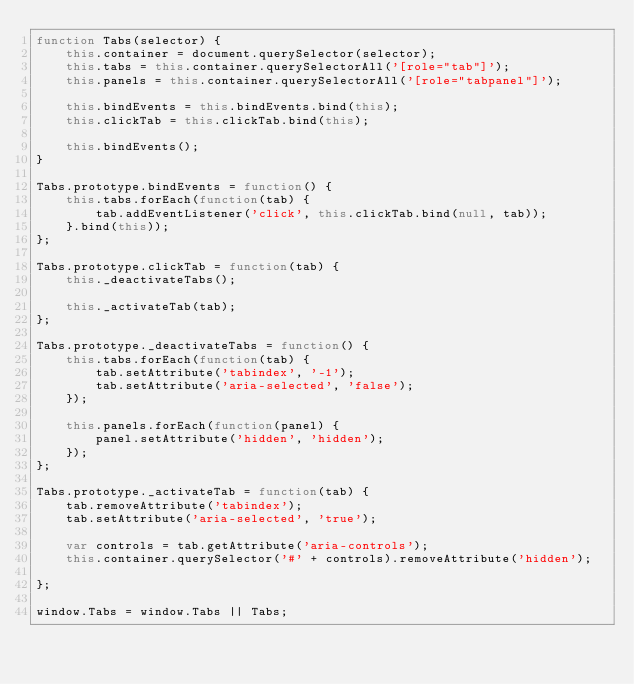Convert code to text. <code><loc_0><loc_0><loc_500><loc_500><_JavaScript_>function Tabs(selector) {
    this.container = document.querySelector(selector);
    this.tabs = this.container.querySelectorAll('[role="tab"]');
    this.panels = this.container.querySelectorAll('[role="tabpanel"]');

    this.bindEvents = this.bindEvents.bind(this);
    this.clickTab = this.clickTab.bind(this);

    this.bindEvents();
}

Tabs.prototype.bindEvents = function() {
    this.tabs.forEach(function(tab) {
        tab.addEventListener('click', this.clickTab.bind(null, tab));
    }.bind(this));
};

Tabs.prototype.clickTab = function(tab) {
    this._deactivateTabs();

    this._activateTab(tab);
};

Tabs.prototype._deactivateTabs = function() {
    this.tabs.forEach(function(tab) {
        tab.setAttribute('tabindex', '-1');
        tab.setAttribute('aria-selected', 'false');
    });

    this.panels.forEach(function(panel) {
        panel.setAttribute('hidden', 'hidden');
    });
};

Tabs.prototype._activateTab = function(tab) {
    tab.removeAttribute('tabindex');
    tab.setAttribute('aria-selected', 'true');

    var controls = tab.getAttribute('aria-controls');
    this.container.querySelector('#' + controls).removeAttribute('hidden');

};

window.Tabs = window.Tabs || Tabs;
</code> 